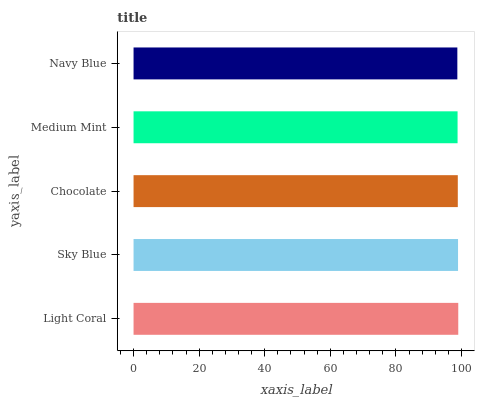Is Navy Blue the minimum?
Answer yes or no. Yes. Is Light Coral the maximum?
Answer yes or no. Yes. Is Sky Blue the minimum?
Answer yes or no. No. Is Sky Blue the maximum?
Answer yes or no. No. Is Light Coral greater than Sky Blue?
Answer yes or no. Yes. Is Sky Blue less than Light Coral?
Answer yes or no. Yes. Is Sky Blue greater than Light Coral?
Answer yes or no. No. Is Light Coral less than Sky Blue?
Answer yes or no. No. Is Chocolate the high median?
Answer yes or no. Yes. Is Chocolate the low median?
Answer yes or no. Yes. Is Light Coral the high median?
Answer yes or no. No. Is Navy Blue the low median?
Answer yes or no. No. 